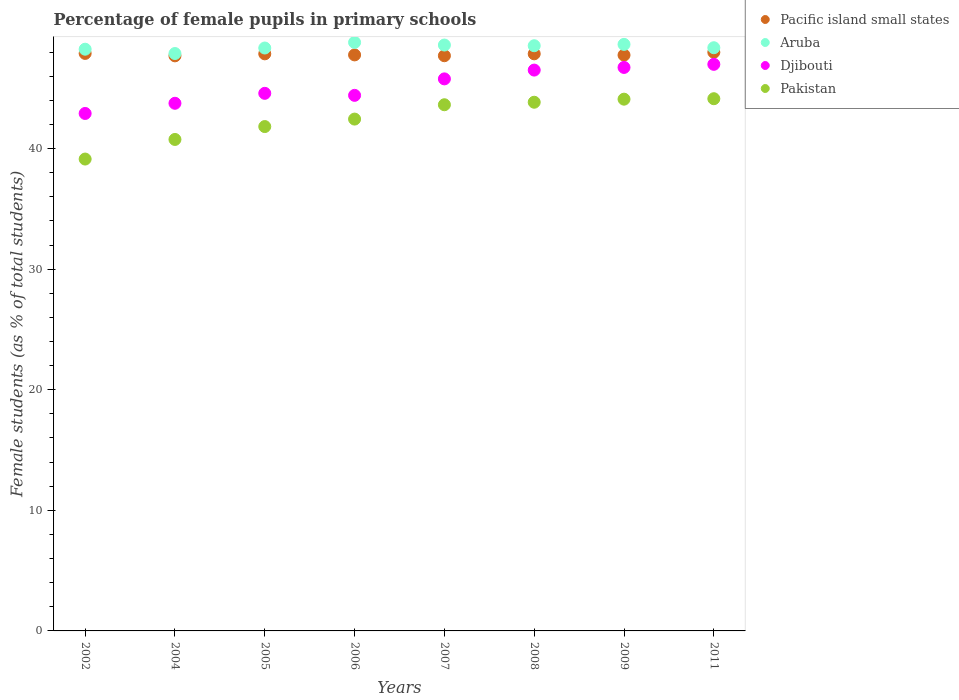What is the percentage of female pupils in primary schools in Pakistan in 2002?
Keep it short and to the point. 39.13. Across all years, what is the maximum percentage of female pupils in primary schools in Djibouti?
Offer a terse response. 46.99. Across all years, what is the minimum percentage of female pupils in primary schools in Pacific island small states?
Your response must be concise. 47.69. What is the total percentage of female pupils in primary schools in Pacific island small states in the graph?
Offer a very short reply. 382.52. What is the difference between the percentage of female pupils in primary schools in Djibouti in 2007 and that in 2011?
Your answer should be very brief. -1.21. What is the difference between the percentage of female pupils in primary schools in Djibouti in 2006 and the percentage of female pupils in primary schools in Pacific island small states in 2007?
Provide a short and direct response. -3.29. What is the average percentage of female pupils in primary schools in Djibouti per year?
Your answer should be very brief. 45.21. In the year 2008, what is the difference between the percentage of female pupils in primary schools in Pakistan and percentage of female pupils in primary schools in Djibouti?
Keep it short and to the point. -2.67. What is the ratio of the percentage of female pupils in primary schools in Pakistan in 2006 to that in 2007?
Keep it short and to the point. 0.97. Is the difference between the percentage of female pupils in primary schools in Pakistan in 2005 and 2007 greater than the difference between the percentage of female pupils in primary schools in Djibouti in 2005 and 2007?
Give a very brief answer. No. What is the difference between the highest and the second highest percentage of female pupils in primary schools in Pacific island small states?
Provide a short and direct response. 0.1. What is the difference between the highest and the lowest percentage of female pupils in primary schools in Aruba?
Offer a very short reply. 0.92. In how many years, is the percentage of female pupils in primary schools in Djibouti greater than the average percentage of female pupils in primary schools in Djibouti taken over all years?
Offer a terse response. 4. Is it the case that in every year, the sum of the percentage of female pupils in primary schools in Djibouti and percentage of female pupils in primary schools in Aruba  is greater than the sum of percentage of female pupils in primary schools in Pacific island small states and percentage of female pupils in primary schools in Pakistan?
Your answer should be compact. Yes. Is the percentage of female pupils in primary schools in Djibouti strictly less than the percentage of female pupils in primary schools in Pakistan over the years?
Your answer should be compact. No. How many dotlines are there?
Provide a succinct answer. 4. What is the difference between two consecutive major ticks on the Y-axis?
Make the answer very short. 10. Are the values on the major ticks of Y-axis written in scientific E-notation?
Your answer should be compact. No. Does the graph contain any zero values?
Provide a short and direct response. No. Where does the legend appear in the graph?
Offer a very short reply. Top right. How many legend labels are there?
Offer a very short reply. 4. How are the legend labels stacked?
Offer a very short reply. Vertical. What is the title of the graph?
Provide a short and direct response. Percentage of female pupils in primary schools. Does "Cameroon" appear as one of the legend labels in the graph?
Provide a short and direct response. No. What is the label or title of the X-axis?
Provide a short and direct response. Years. What is the label or title of the Y-axis?
Offer a terse response. Female students (as % of total students). What is the Female students (as % of total students) in Pacific island small states in 2002?
Provide a short and direct response. 47.89. What is the Female students (as % of total students) of Aruba in 2002?
Give a very brief answer. 48.24. What is the Female students (as % of total students) of Djibouti in 2002?
Ensure brevity in your answer.  42.91. What is the Female students (as % of total students) of Pakistan in 2002?
Offer a terse response. 39.13. What is the Female students (as % of total students) in Pacific island small states in 2004?
Make the answer very short. 47.69. What is the Female students (as % of total students) of Aruba in 2004?
Your answer should be very brief. 47.88. What is the Female students (as % of total students) in Djibouti in 2004?
Provide a short and direct response. 43.76. What is the Female students (as % of total students) in Pakistan in 2004?
Provide a short and direct response. 40.76. What is the Female students (as % of total students) of Pacific island small states in 2005?
Your answer should be compact. 47.86. What is the Female students (as % of total students) in Aruba in 2005?
Ensure brevity in your answer.  48.34. What is the Female students (as % of total students) of Djibouti in 2005?
Provide a short and direct response. 44.58. What is the Female students (as % of total students) in Pakistan in 2005?
Provide a succinct answer. 41.83. What is the Female students (as % of total students) in Pacific island small states in 2006?
Provide a short and direct response. 47.77. What is the Female students (as % of total students) of Aruba in 2006?
Provide a short and direct response. 48.81. What is the Female students (as % of total students) in Djibouti in 2006?
Give a very brief answer. 44.42. What is the Female students (as % of total students) in Pakistan in 2006?
Your answer should be compact. 42.45. What is the Female students (as % of total students) in Pacific island small states in 2007?
Provide a short and direct response. 47.7. What is the Female students (as % of total students) of Aruba in 2007?
Give a very brief answer. 48.59. What is the Female students (as % of total students) of Djibouti in 2007?
Your response must be concise. 45.78. What is the Female students (as % of total students) of Pakistan in 2007?
Keep it short and to the point. 43.64. What is the Female students (as % of total students) of Pacific island small states in 2008?
Offer a terse response. 47.86. What is the Female students (as % of total students) of Aruba in 2008?
Your answer should be very brief. 48.53. What is the Female students (as % of total students) in Djibouti in 2008?
Your response must be concise. 46.51. What is the Female students (as % of total students) of Pakistan in 2008?
Offer a very short reply. 43.84. What is the Female students (as % of total students) of Pacific island small states in 2009?
Give a very brief answer. 47.75. What is the Female students (as % of total students) in Aruba in 2009?
Provide a short and direct response. 48.64. What is the Female students (as % of total students) of Djibouti in 2009?
Keep it short and to the point. 46.73. What is the Female students (as % of total students) of Pakistan in 2009?
Give a very brief answer. 44.1. What is the Female students (as % of total students) in Pacific island small states in 2011?
Keep it short and to the point. 47.99. What is the Female students (as % of total students) of Aruba in 2011?
Your response must be concise. 48.36. What is the Female students (as % of total students) of Djibouti in 2011?
Offer a terse response. 46.99. What is the Female students (as % of total students) in Pakistan in 2011?
Give a very brief answer. 44.14. Across all years, what is the maximum Female students (as % of total students) of Pacific island small states?
Ensure brevity in your answer.  47.99. Across all years, what is the maximum Female students (as % of total students) in Aruba?
Provide a succinct answer. 48.81. Across all years, what is the maximum Female students (as % of total students) of Djibouti?
Ensure brevity in your answer.  46.99. Across all years, what is the maximum Female students (as % of total students) in Pakistan?
Offer a very short reply. 44.14. Across all years, what is the minimum Female students (as % of total students) of Pacific island small states?
Provide a succinct answer. 47.69. Across all years, what is the minimum Female students (as % of total students) of Aruba?
Your answer should be very brief. 47.88. Across all years, what is the minimum Female students (as % of total students) of Djibouti?
Keep it short and to the point. 42.91. Across all years, what is the minimum Female students (as % of total students) of Pakistan?
Your response must be concise. 39.13. What is the total Female students (as % of total students) in Pacific island small states in the graph?
Give a very brief answer. 382.52. What is the total Female students (as % of total students) in Aruba in the graph?
Make the answer very short. 387.4. What is the total Female students (as % of total students) in Djibouti in the graph?
Your response must be concise. 361.68. What is the total Female students (as % of total students) in Pakistan in the graph?
Your answer should be compact. 339.88. What is the difference between the Female students (as % of total students) of Pacific island small states in 2002 and that in 2004?
Your answer should be compact. 0.2. What is the difference between the Female students (as % of total students) of Aruba in 2002 and that in 2004?
Keep it short and to the point. 0.36. What is the difference between the Female students (as % of total students) of Djibouti in 2002 and that in 2004?
Make the answer very short. -0.84. What is the difference between the Female students (as % of total students) in Pakistan in 2002 and that in 2004?
Your answer should be very brief. -1.63. What is the difference between the Female students (as % of total students) in Pacific island small states in 2002 and that in 2005?
Your answer should be compact. 0.04. What is the difference between the Female students (as % of total students) of Aruba in 2002 and that in 2005?
Provide a short and direct response. -0.1. What is the difference between the Female students (as % of total students) in Djibouti in 2002 and that in 2005?
Your answer should be very brief. -1.67. What is the difference between the Female students (as % of total students) in Pakistan in 2002 and that in 2005?
Provide a succinct answer. -2.69. What is the difference between the Female students (as % of total students) in Pacific island small states in 2002 and that in 2006?
Offer a terse response. 0.12. What is the difference between the Female students (as % of total students) in Aruba in 2002 and that in 2006?
Make the answer very short. -0.56. What is the difference between the Female students (as % of total students) in Djibouti in 2002 and that in 2006?
Your answer should be compact. -1.5. What is the difference between the Female students (as % of total students) of Pakistan in 2002 and that in 2006?
Ensure brevity in your answer.  -3.31. What is the difference between the Female students (as % of total students) in Pacific island small states in 2002 and that in 2007?
Offer a very short reply. 0.19. What is the difference between the Female students (as % of total students) of Aruba in 2002 and that in 2007?
Give a very brief answer. -0.35. What is the difference between the Female students (as % of total students) in Djibouti in 2002 and that in 2007?
Ensure brevity in your answer.  -2.87. What is the difference between the Female students (as % of total students) in Pakistan in 2002 and that in 2007?
Ensure brevity in your answer.  -4.5. What is the difference between the Female students (as % of total students) of Pacific island small states in 2002 and that in 2008?
Your response must be concise. 0.03. What is the difference between the Female students (as % of total students) in Aruba in 2002 and that in 2008?
Offer a terse response. -0.29. What is the difference between the Female students (as % of total students) of Djibouti in 2002 and that in 2008?
Provide a succinct answer. -3.6. What is the difference between the Female students (as % of total students) of Pakistan in 2002 and that in 2008?
Make the answer very short. -4.71. What is the difference between the Female students (as % of total students) in Pacific island small states in 2002 and that in 2009?
Your answer should be compact. 0.14. What is the difference between the Female students (as % of total students) in Aruba in 2002 and that in 2009?
Your answer should be very brief. -0.4. What is the difference between the Female students (as % of total students) of Djibouti in 2002 and that in 2009?
Make the answer very short. -3.82. What is the difference between the Female students (as % of total students) of Pakistan in 2002 and that in 2009?
Your answer should be compact. -4.97. What is the difference between the Female students (as % of total students) in Pacific island small states in 2002 and that in 2011?
Your response must be concise. -0.1. What is the difference between the Female students (as % of total students) of Aruba in 2002 and that in 2011?
Provide a short and direct response. -0.12. What is the difference between the Female students (as % of total students) of Djibouti in 2002 and that in 2011?
Your response must be concise. -4.07. What is the difference between the Female students (as % of total students) of Pakistan in 2002 and that in 2011?
Your answer should be compact. -5. What is the difference between the Female students (as % of total students) of Pacific island small states in 2004 and that in 2005?
Ensure brevity in your answer.  -0.17. What is the difference between the Female students (as % of total students) of Aruba in 2004 and that in 2005?
Provide a succinct answer. -0.46. What is the difference between the Female students (as % of total students) in Djibouti in 2004 and that in 2005?
Make the answer very short. -0.83. What is the difference between the Female students (as % of total students) in Pakistan in 2004 and that in 2005?
Ensure brevity in your answer.  -1.07. What is the difference between the Female students (as % of total students) in Pacific island small states in 2004 and that in 2006?
Give a very brief answer. -0.08. What is the difference between the Female students (as % of total students) in Aruba in 2004 and that in 2006?
Your response must be concise. -0.92. What is the difference between the Female students (as % of total students) in Djibouti in 2004 and that in 2006?
Provide a short and direct response. -0.66. What is the difference between the Female students (as % of total students) in Pakistan in 2004 and that in 2006?
Provide a short and direct response. -1.69. What is the difference between the Female students (as % of total students) of Pacific island small states in 2004 and that in 2007?
Keep it short and to the point. -0.01. What is the difference between the Female students (as % of total students) of Aruba in 2004 and that in 2007?
Offer a terse response. -0.7. What is the difference between the Female students (as % of total students) in Djibouti in 2004 and that in 2007?
Offer a very short reply. -2.02. What is the difference between the Female students (as % of total students) in Pakistan in 2004 and that in 2007?
Keep it short and to the point. -2.88. What is the difference between the Female students (as % of total students) of Pacific island small states in 2004 and that in 2008?
Ensure brevity in your answer.  -0.17. What is the difference between the Female students (as % of total students) of Aruba in 2004 and that in 2008?
Offer a very short reply. -0.65. What is the difference between the Female students (as % of total students) of Djibouti in 2004 and that in 2008?
Give a very brief answer. -2.75. What is the difference between the Female students (as % of total students) of Pakistan in 2004 and that in 2008?
Keep it short and to the point. -3.09. What is the difference between the Female students (as % of total students) in Pacific island small states in 2004 and that in 2009?
Keep it short and to the point. -0.06. What is the difference between the Female students (as % of total students) of Aruba in 2004 and that in 2009?
Offer a terse response. -0.76. What is the difference between the Female students (as % of total students) of Djibouti in 2004 and that in 2009?
Your response must be concise. -2.97. What is the difference between the Female students (as % of total students) of Pakistan in 2004 and that in 2009?
Keep it short and to the point. -3.34. What is the difference between the Female students (as % of total students) of Pacific island small states in 2004 and that in 2011?
Ensure brevity in your answer.  -0.3. What is the difference between the Female students (as % of total students) of Aruba in 2004 and that in 2011?
Provide a short and direct response. -0.48. What is the difference between the Female students (as % of total students) in Djibouti in 2004 and that in 2011?
Keep it short and to the point. -3.23. What is the difference between the Female students (as % of total students) of Pakistan in 2004 and that in 2011?
Your answer should be very brief. -3.38. What is the difference between the Female students (as % of total students) of Pacific island small states in 2005 and that in 2006?
Your answer should be very brief. 0.09. What is the difference between the Female students (as % of total students) of Aruba in 2005 and that in 2006?
Provide a succinct answer. -0.47. What is the difference between the Female students (as % of total students) in Djibouti in 2005 and that in 2006?
Offer a very short reply. 0.17. What is the difference between the Female students (as % of total students) of Pakistan in 2005 and that in 2006?
Offer a terse response. -0.62. What is the difference between the Female students (as % of total students) of Pacific island small states in 2005 and that in 2007?
Your response must be concise. 0.16. What is the difference between the Female students (as % of total students) of Aruba in 2005 and that in 2007?
Keep it short and to the point. -0.25. What is the difference between the Female students (as % of total students) in Djibouti in 2005 and that in 2007?
Offer a terse response. -1.2. What is the difference between the Female students (as % of total students) of Pakistan in 2005 and that in 2007?
Ensure brevity in your answer.  -1.81. What is the difference between the Female students (as % of total students) of Pacific island small states in 2005 and that in 2008?
Offer a very short reply. -0. What is the difference between the Female students (as % of total students) of Aruba in 2005 and that in 2008?
Provide a short and direct response. -0.19. What is the difference between the Female students (as % of total students) in Djibouti in 2005 and that in 2008?
Ensure brevity in your answer.  -1.93. What is the difference between the Female students (as % of total students) of Pakistan in 2005 and that in 2008?
Your response must be concise. -2.02. What is the difference between the Female students (as % of total students) of Pacific island small states in 2005 and that in 2009?
Give a very brief answer. 0.1. What is the difference between the Female students (as % of total students) in Aruba in 2005 and that in 2009?
Offer a terse response. -0.3. What is the difference between the Female students (as % of total students) of Djibouti in 2005 and that in 2009?
Keep it short and to the point. -2.15. What is the difference between the Female students (as % of total students) in Pakistan in 2005 and that in 2009?
Provide a short and direct response. -2.27. What is the difference between the Female students (as % of total students) in Pacific island small states in 2005 and that in 2011?
Your answer should be compact. -0.13. What is the difference between the Female students (as % of total students) in Aruba in 2005 and that in 2011?
Your answer should be very brief. -0.02. What is the difference between the Female students (as % of total students) in Djibouti in 2005 and that in 2011?
Keep it short and to the point. -2.4. What is the difference between the Female students (as % of total students) in Pakistan in 2005 and that in 2011?
Your answer should be very brief. -2.31. What is the difference between the Female students (as % of total students) of Pacific island small states in 2006 and that in 2007?
Give a very brief answer. 0.07. What is the difference between the Female students (as % of total students) in Aruba in 2006 and that in 2007?
Keep it short and to the point. 0.22. What is the difference between the Female students (as % of total students) of Djibouti in 2006 and that in 2007?
Offer a very short reply. -1.37. What is the difference between the Female students (as % of total students) of Pakistan in 2006 and that in 2007?
Ensure brevity in your answer.  -1.19. What is the difference between the Female students (as % of total students) in Pacific island small states in 2006 and that in 2008?
Offer a very short reply. -0.09. What is the difference between the Female students (as % of total students) in Aruba in 2006 and that in 2008?
Offer a terse response. 0.27. What is the difference between the Female students (as % of total students) of Djibouti in 2006 and that in 2008?
Your answer should be very brief. -2.1. What is the difference between the Female students (as % of total students) in Pakistan in 2006 and that in 2008?
Your answer should be compact. -1.4. What is the difference between the Female students (as % of total students) of Pacific island small states in 2006 and that in 2009?
Your answer should be very brief. 0.02. What is the difference between the Female students (as % of total students) of Aruba in 2006 and that in 2009?
Give a very brief answer. 0.16. What is the difference between the Female students (as % of total students) in Djibouti in 2006 and that in 2009?
Offer a very short reply. -2.32. What is the difference between the Female students (as % of total students) in Pakistan in 2006 and that in 2009?
Keep it short and to the point. -1.65. What is the difference between the Female students (as % of total students) in Pacific island small states in 2006 and that in 2011?
Provide a succinct answer. -0.22. What is the difference between the Female students (as % of total students) in Aruba in 2006 and that in 2011?
Give a very brief answer. 0.44. What is the difference between the Female students (as % of total students) in Djibouti in 2006 and that in 2011?
Provide a succinct answer. -2.57. What is the difference between the Female students (as % of total students) in Pakistan in 2006 and that in 2011?
Offer a very short reply. -1.69. What is the difference between the Female students (as % of total students) in Pacific island small states in 2007 and that in 2008?
Offer a very short reply. -0.16. What is the difference between the Female students (as % of total students) in Aruba in 2007 and that in 2008?
Offer a terse response. 0.06. What is the difference between the Female students (as % of total students) in Djibouti in 2007 and that in 2008?
Keep it short and to the point. -0.73. What is the difference between the Female students (as % of total students) of Pakistan in 2007 and that in 2008?
Your answer should be very brief. -0.21. What is the difference between the Female students (as % of total students) in Pacific island small states in 2007 and that in 2009?
Make the answer very short. -0.05. What is the difference between the Female students (as % of total students) in Aruba in 2007 and that in 2009?
Provide a succinct answer. -0.05. What is the difference between the Female students (as % of total students) of Djibouti in 2007 and that in 2009?
Provide a succinct answer. -0.95. What is the difference between the Female students (as % of total students) of Pakistan in 2007 and that in 2009?
Provide a short and direct response. -0.46. What is the difference between the Female students (as % of total students) in Pacific island small states in 2007 and that in 2011?
Provide a succinct answer. -0.29. What is the difference between the Female students (as % of total students) of Aruba in 2007 and that in 2011?
Make the answer very short. 0.22. What is the difference between the Female students (as % of total students) in Djibouti in 2007 and that in 2011?
Your response must be concise. -1.21. What is the difference between the Female students (as % of total students) of Pakistan in 2007 and that in 2011?
Provide a short and direct response. -0.5. What is the difference between the Female students (as % of total students) in Pacific island small states in 2008 and that in 2009?
Your answer should be very brief. 0.11. What is the difference between the Female students (as % of total students) in Aruba in 2008 and that in 2009?
Provide a short and direct response. -0.11. What is the difference between the Female students (as % of total students) of Djibouti in 2008 and that in 2009?
Your answer should be compact. -0.22. What is the difference between the Female students (as % of total students) in Pakistan in 2008 and that in 2009?
Ensure brevity in your answer.  -0.25. What is the difference between the Female students (as % of total students) of Pacific island small states in 2008 and that in 2011?
Your response must be concise. -0.13. What is the difference between the Female students (as % of total students) in Aruba in 2008 and that in 2011?
Offer a very short reply. 0.17. What is the difference between the Female students (as % of total students) in Djibouti in 2008 and that in 2011?
Your answer should be compact. -0.48. What is the difference between the Female students (as % of total students) in Pakistan in 2008 and that in 2011?
Provide a short and direct response. -0.29. What is the difference between the Female students (as % of total students) in Pacific island small states in 2009 and that in 2011?
Offer a very short reply. -0.23. What is the difference between the Female students (as % of total students) of Aruba in 2009 and that in 2011?
Your response must be concise. 0.28. What is the difference between the Female students (as % of total students) of Djibouti in 2009 and that in 2011?
Keep it short and to the point. -0.26. What is the difference between the Female students (as % of total students) of Pakistan in 2009 and that in 2011?
Keep it short and to the point. -0.04. What is the difference between the Female students (as % of total students) in Pacific island small states in 2002 and the Female students (as % of total students) in Aruba in 2004?
Provide a short and direct response. 0.01. What is the difference between the Female students (as % of total students) of Pacific island small states in 2002 and the Female students (as % of total students) of Djibouti in 2004?
Provide a short and direct response. 4.14. What is the difference between the Female students (as % of total students) in Pacific island small states in 2002 and the Female students (as % of total students) in Pakistan in 2004?
Offer a terse response. 7.14. What is the difference between the Female students (as % of total students) of Aruba in 2002 and the Female students (as % of total students) of Djibouti in 2004?
Offer a very short reply. 4.48. What is the difference between the Female students (as % of total students) in Aruba in 2002 and the Female students (as % of total students) in Pakistan in 2004?
Your answer should be compact. 7.48. What is the difference between the Female students (as % of total students) of Djibouti in 2002 and the Female students (as % of total students) of Pakistan in 2004?
Provide a short and direct response. 2.16. What is the difference between the Female students (as % of total students) in Pacific island small states in 2002 and the Female students (as % of total students) in Aruba in 2005?
Ensure brevity in your answer.  -0.45. What is the difference between the Female students (as % of total students) in Pacific island small states in 2002 and the Female students (as % of total students) in Djibouti in 2005?
Provide a succinct answer. 3.31. What is the difference between the Female students (as % of total students) of Pacific island small states in 2002 and the Female students (as % of total students) of Pakistan in 2005?
Make the answer very short. 6.07. What is the difference between the Female students (as % of total students) of Aruba in 2002 and the Female students (as % of total students) of Djibouti in 2005?
Offer a terse response. 3.66. What is the difference between the Female students (as % of total students) of Aruba in 2002 and the Female students (as % of total students) of Pakistan in 2005?
Provide a succinct answer. 6.41. What is the difference between the Female students (as % of total students) in Djibouti in 2002 and the Female students (as % of total students) in Pakistan in 2005?
Your answer should be very brief. 1.09. What is the difference between the Female students (as % of total students) of Pacific island small states in 2002 and the Female students (as % of total students) of Aruba in 2006?
Offer a terse response. -0.91. What is the difference between the Female students (as % of total students) of Pacific island small states in 2002 and the Female students (as % of total students) of Djibouti in 2006?
Provide a short and direct response. 3.48. What is the difference between the Female students (as % of total students) of Pacific island small states in 2002 and the Female students (as % of total students) of Pakistan in 2006?
Ensure brevity in your answer.  5.45. What is the difference between the Female students (as % of total students) in Aruba in 2002 and the Female students (as % of total students) in Djibouti in 2006?
Your answer should be compact. 3.83. What is the difference between the Female students (as % of total students) of Aruba in 2002 and the Female students (as % of total students) of Pakistan in 2006?
Keep it short and to the point. 5.79. What is the difference between the Female students (as % of total students) of Djibouti in 2002 and the Female students (as % of total students) of Pakistan in 2006?
Your answer should be very brief. 0.47. What is the difference between the Female students (as % of total students) of Pacific island small states in 2002 and the Female students (as % of total students) of Aruba in 2007?
Your answer should be very brief. -0.7. What is the difference between the Female students (as % of total students) of Pacific island small states in 2002 and the Female students (as % of total students) of Djibouti in 2007?
Ensure brevity in your answer.  2.11. What is the difference between the Female students (as % of total students) of Pacific island small states in 2002 and the Female students (as % of total students) of Pakistan in 2007?
Make the answer very short. 4.26. What is the difference between the Female students (as % of total students) of Aruba in 2002 and the Female students (as % of total students) of Djibouti in 2007?
Offer a very short reply. 2.46. What is the difference between the Female students (as % of total students) in Aruba in 2002 and the Female students (as % of total students) in Pakistan in 2007?
Offer a very short reply. 4.61. What is the difference between the Female students (as % of total students) of Djibouti in 2002 and the Female students (as % of total students) of Pakistan in 2007?
Offer a terse response. -0.72. What is the difference between the Female students (as % of total students) of Pacific island small states in 2002 and the Female students (as % of total students) of Aruba in 2008?
Your answer should be very brief. -0.64. What is the difference between the Female students (as % of total students) of Pacific island small states in 2002 and the Female students (as % of total students) of Djibouti in 2008?
Provide a short and direct response. 1.38. What is the difference between the Female students (as % of total students) in Pacific island small states in 2002 and the Female students (as % of total students) in Pakistan in 2008?
Your answer should be compact. 4.05. What is the difference between the Female students (as % of total students) in Aruba in 2002 and the Female students (as % of total students) in Djibouti in 2008?
Offer a terse response. 1.73. What is the difference between the Female students (as % of total students) of Aruba in 2002 and the Female students (as % of total students) of Pakistan in 2008?
Provide a short and direct response. 4.4. What is the difference between the Female students (as % of total students) in Djibouti in 2002 and the Female students (as % of total students) in Pakistan in 2008?
Your answer should be compact. -0.93. What is the difference between the Female students (as % of total students) in Pacific island small states in 2002 and the Female students (as % of total students) in Aruba in 2009?
Keep it short and to the point. -0.75. What is the difference between the Female students (as % of total students) of Pacific island small states in 2002 and the Female students (as % of total students) of Djibouti in 2009?
Offer a very short reply. 1.16. What is the difference between the Female students (as % of total students) of Pacific island small states in 2002 and the Female students (as % of total students) of Pakistan in 2009?
Keep it short and to the point. 3.79. What is the difference between the Female students (as % of total students) in Aruba in 2002 and the Female students (as % of total students) in Djibouti in 2009?
Give a very brief answer. 1.51. What is the difference between the Female students (as % of total students) in Aruba in 2002 and the Female students (as % of total students) in Pakistan in 2009?
Ensure brevity in your answer.  4.14. What is the difference between the Female students (as % of total students) of Djibouti in 2002 and the Female students (as % of total students) of Pakistan in 2009?
Offer a very short reply. -1.18. What is the difference between the Female students (as % of total students) of Pacific island small states in 2002 and the Female students (as % of total students) of Aruba in 2011?
Your answer should be very brief. -0.47. What is the difference between the Female students (as % of total students) of Pacific island small states in 2002 and the Female students (as % of total students) of Djibouti in 2011?
Your answer should be very brief. 0.91. What is the difference between the Female students (as % of total students) of Pacific island small states in 2002 and the Female students (as % of total students) of Pakistan in 2011?
Provide a succinct answer. 3.76. What is the difference between the Female students (as % of total students) in Aruba in 2002 and the Female students (as % of total students) in Djibouti in 2011?
Provide a succinct answer. 1.25. What is the difference between the Female students (as % of total students) in Aruba in 2002 and the Female students (as % of total students) in Pakistan in 2011?
Provide a succinct answer. 4.11. What is the difference between the Female students (as % of total students) of Djibouti in 2002 and the Female students (as % of total students) of Pakistan in 2011?
Provide a succinct answer. -1.22. What is the difference between the Female students (as % of total students) of Pacific island small states in 2004 and the Female students (as % of total students) of Aruba in 2005?
Give a very brief answer. -0.65. What is the difference between the Female students (as % of total students) in Pacific island small states in 2004 and the Female students (as % of total students) in Djibouti in 2005?
Keep it short and to the point. 3.11. What is the difference between the Female students (as % of total students) in Pacific island small states in 2004 and the Female students (as % of total students) in Pakistan in 2005?
Offer a very short reply. 5.86. What is the difference between the Female students (as % of total students) of Aruba in 2004 and the Female students (as % of total students) of Djibouti in 2005?
Offer a terse response. 3.3. What is the difference between the Female students (as % of total students) of Aruba in 2004 and the Female students (as % of total students) of Pakistan in 2005?
Your answer should be compact. 6.06. What is the difference between the Female students (as % of total students) in Djibouti in 2004 and the Female students (as % of total students) in Pakistan in 2005?
Ensure brevity in your answer.  1.93. What is the difference between the Female students (as % of total students) in Pacific island small states in 2004 and the Female students (as % of total students) in Aruba in 2006?
Provide a succinct answer. -1.11. What is the difference between the Female students (as % of total students) of Pacific island small states in 2004 and the Female students (as % of total students) of Djibouti in 2006?
Provide a succinct answer. 3.28. What is the difference between the Female students (as % of total students) of Pacific island small states in 2004 and the Female students (as % of total students) of Pakistan in 2006?
Your response must be concise. 5.24. What is the difference between the Female students (as % of total students) of Aruba in 2004 and the Female students (as % of total students) of Djibouti in 2006?
Provide a succinct answer. 3.47. What is the difference between the Female students (as % of total students) of Aruba in 2004 and the Female students (as % of total students) of Pakistan in 2006?
Provide a short and direct response. 5.44. What is the difference between the Female students (as % of total students) of Djibouti in 2004 and the Female students (as % of total students) of Pakistan in 2006?
Ensure brevity in your answer.  1.31. What is the difference between the Female students (as % of total students) of Pacific island small states in 2004 and the Female students (as % of total students) of Aruba in 2007?
Your response must be concise. -0.9. What is the difference between the Female students (as % of total students) in Pacific island small states in 2004 and the Female students (as % of total students) in Djibouti in 2007?
Your answer should be very brief. 1.91. What is the difference between the Female students (as % of total students) of Pacific island small states in 2004 and the Female students (as % of total students) of Pakistan in 2007?
Your answer should be very brief. 4.06. What is the difference between the Female students (as % of total students) in Aruba in 2004 and the Female students (as % of total students) in Djibouti in 2007?
Provide a succinct answer. 2.1. What is the difference between the Female students (as % of total students) of Aruba in 2004 and the Female students (as % of total students) of Pakistan in 2007?
Make the answer very short. 4.25. What is the difference between the Female students (as % of total students) in Djibouti in 2004 and the Female students (as % of total students) in Pakistan in 2007?
Ensure brevity in your answer.  0.12. What is the difference between the Female students (as % of total students) in Pacific island small states in 2004 and the Female students (as % of total students) in Aruba in 2008?
Make the answer very short. -0.84. What is the difference between the Female students (as % of total students) of Pacific island small states in 2004 and the Female students (as % of total students) of Djibouti in 2008?
Give a very brief answer. 1.18. What is the difference between the Female students (as % of total students) of Pacific island small states in 2004 and the Female students (as % of total students) of Pakistan in 2008?
Your response must be concise. 3.85. What is the difference between the Female students (as % of total students) of Aruba in 2004 and the Female students (as % of total students) of Djibouti in 2008?
Provide a succinct answer. 1.37. What is the difference between the Female students (as % of total students) in Aruba in 2004 and the Female students (as % of total students) in Pakistan in 2008?
Your response must be concise. 4.04. What is the difference between the Female students (as % of total students) in Djibouti in 2004 and the Female students (as % of total students) in Pakistan in 2008?
Your answer should be compact. -0.09. What is the difference between the Female students (as % of total students) in Pacific island small states in 2004 and the Female students (as % of total students) in Aruba in 2009?
Make the answer very short. -0.95. What is the difference between the Female students (as % of total students) in Pacific island small states in 2004 and the Female students (as % of total students) in Djibouti in 2009?
Your answer should be very brief. 0.96. What is the difference between the Female students (as % of total students) of Pacific island small states in 2004 and the Female students (as % of total students) of Pakistan in 2009?
Provide a short and direct response. 3.59. What is the difference between the Female students (as % of total students) in Aruba in 2004 and the Female students (as % of total students) in Djibouti in 2009?
Provide a short and direct response. 1.15. What is the difference between the Female students (as % of total students) in Aruba in 2004 and the Female students (as % of total students) in Pakistan in 2009?
Your answer should be very brief. 3.79. What is the difference between the Female students (as % of total students) in Djibouti in 2004 and the Female students (as % of total students) in Pakistan in 2009?
Give a very brief answer. -0.34. What is the difference between the Female students (as % of total students) of Pacific island small states in 2004 and the Female students (as % of total students) of Aruba in 2011?
Offer a terse response. -0.67. What is the difference between the Female students (as % of total students) of Pacific island small states in 2004 and the Female students (as % of total students) of Djibouti in 2011?
Your answer should be compact. 0.7. What is the difference between the Female students (as % of total students) of Pacific island small states in 2004 and the Female students (as % of total students) of Pakistan in 2011?
Your answer should be compact. 3.56. What is the difference between the Female students (as % of total students) of Aruba in 2004 and the Female students (as % of total students) of Djibouti in 2011?
Your response must be concise. 0.9. What is the difference between the Female students (as % of total students) in Aruba in 2004 and the Female students (as % of total students) in Pakistan in 2011?
Your answer should be compact. 3.75. What is the difference between the Female students (as % of total students) of Djibouti in 2004 and the Female students (as % of total students) of Pakistan in 2011?
Your answer should be very brief. -0.38. What is the difference between the Female students (as % of total students) of Pacific island small states in 2005 and the Female students (as % of total students) of Aruba in 2006?
Your answer should be compact. -0.95. What is the difference between the Female students (as % of total students) of Pacific island small states in 2005 and the Female students (as % of total students) of Djibouti in 2006?
Offer a very short reply. 3.44. What is the difference between the Female students (as % of total students) of Pacific island small states in 2005 and the Female students (as % of total students) of Pakistan in 2006?
Make the answer very short. 5.41. What is the difference between the Female students (as % of total students) of Aruba in 2005 and the Female students (as % of total students) of Djibouti in 2006?
Offer a terse response. 3.93. What is the difference between the Female students (as % of total students) in Aruba in 2005 and the Female students (as % of total students) in Pakistan in 2006?
Offer a terse response. 5.89. What is the difference between the Female students (as % of total students) of Djibouti in 2005 and the Female students (as % of total students) of Pakistan in 2006?
Offer a very short reply. 2.14. What is the difference between the Female students (as % of total students) in Pacific island small states in 2005 and the Female students (as % of total students) in Aruba in 2007?
Offer a very short reply. -0.73. What is the difference between the Female students (as % of total students) in Pacific island small states in 2005 and the Female students (as % of total students) in Djibouti in 2007?
Your answer should be very brief. 2.08. What is the difference between the Female students (as % of total students) of Pacific island small states in 2005 and the Female students (as % of total students) of Pakistan in 2007?
Provide a short and direct response. 4.22. What is the difference between the Female students (as % of total students) in Aruba in 2005 and the Female students (as % of total students) in Djibouti in 2007?
Your answer should be very brief. 2.56. What is the difference between the Female students (as % of total students) of Aruba in 2005 and the Female students (as % of total students) of Pakistan in 2007?
Give a very brief answer. 4.71. What is the difference between the Female students (as % of total students) in Djibouti in 2005 and the Female students (as % of total students) in Pakistan in 2007?
Your answer should be compact. 0.95. What is the difference between the Female students (as % of total students) in Pacific island small states in 2005 and the Female students (as % of total students) in Aruba in 2008?
Give a very brief answer. -0.67. What is the difference between the Female students (as % of total students) in Pacific island small states in 2005 and the Female students (as % of total students) in Djibouti in 2008?
Offer a very short reply. 1.35. What is the difference between the Female students (as % of total students) of Pacific island small states in 2005 and the Female students (as % of total students) of Pakistan in 2008?
Offer a terse response. 4.01. What is the difference between the Female students (as % of total students) in Aruba in 2005 and the Female students (as % of total students) in Djibouti in 2008?
Provide a short and direct response. 1.83. What is the difference between the Female students (as % of total students) in Aruba in 2005 and the Female students (as % of total students) in Pakistan in 2008?
Ensure brevity in your answer.  4.5. What is the difference between the Female students (as % of total students) of Djibouti in 2005 and the Female students (as % of total students) of Pakistan in 2008?
Provide a short and direct response. 0.74. What is the difference between the Female students (as % of total students) of Pacific island small states in 2005 and the Female students (as % of total students) of Aruba in 2009?
Ensure brevity in your answer.  -0.78. What is the difference between the Female students (as % of total students) of Pacific island small states in 2005 and the Female students (as % of total students) of Djibouti in 2009?
Give a very brief answer. 1.13. What is the difference between the Female students (as % of total students) in Pacific island small states in 2005 and the Female students (as % of total students) in Pakistan in 2009?
Your answer should be compact. 3.76. What is the difference between the Female students (as % of total students) in Aruba in 2005 and the Female students (as % of total students) in Djibouti in 2009?
Offer a terse response. 1.61. What is the difference between the Female students (as % of total students) of Aruba in 2005 and the Female students (as % of total students) of Pakistan in 2009?
Provide a succinct answer. 4.24. What is the difference between the Female students (as % of total students) in Djibouti in 2005 and the Female students (as % of total students) in Pakistan in 2009?
Provide a succinct answer. 0.48. What is the difference between the Female students (as % of total students) in Pacific island small states in 2005 and the Female students (as % of total students) in Aruba in 2011?
Offer a terse response. -0.51. What is the difference between the Female students (as % of total students) of Pacific island small states in 2005 and the Female students (as % of total students) of Djibouti in 2011?
Provide a succinct answer. 0.87. What is the difference between the Female students (as % of total students) of Pacific island small states in 2005 and the Female students (as % of total students) of Pakistan in 2011?
Provide a succinct answer. 3.72. What is the difference between the Female students (as % of total students) in Aruba in 2005 and the Female students (as % of total students) in Djibouti in 2011?
Keep it short and to the point. 1.35. What is the difference between the Female students (as % of total students) of Aruba in 2005 and the Female students (as % of total students) of Pakistan in 2011?
Your response must be concise. 4.2. What is the difference between the Female students (as % of total students) of Djibouti in 2005 and the Female students (as % of total students) of Pakistan in 2011?
Offer a very short reply. 0.45. What is the difference between the Female students (as % of total students) of Pacific island small states in 2006 and the Female students (as % of total students) of Aruba in 2007?
Your response must be concise. -0.82. What is the difference between the Female students (as % of total students) of Pacific island small states in 2006 and the Female students (as % of total students) of Djibouti in 2007?
Your answer should be very brief. 1.99. What is the difference between the Female students (as % of total students) in Pacific island small states in 2006 and the Female students (as % of total students) in Pakistan in 2007?
Offer a terse response. 4.13. What is the difference between the Female students (as % of total students) of Aruba in 2006 and the Female students (as % of total students) of Djibouti in 2007?
Your response must be concise. 3.02. What is the difference between the Female students (as % of total students) of Aruba in 2006 and the Female students (as % of total students) of Pakistan in 2007?
Make the answer very short. 5.17. What is the difference between the Female students (as % of total students) in Djibouti in 2006 and the Female students (as % of total students) in Pakistan in 2007?
Provide a succinct answer. 0.78. What is the difference between the Female students (as % of total students) in Pacific island small states in 2006 and the Female students (as % of total students) in Aruba in 2008?
Your response must be concise. -0.76. What is the difference between the Female students (as % of total students) of Pacific island small states in 2006 and the Female students (as % of total students) of Djibouti in 2008?
Keep it short and to the point. 1.26. What is the difference between the Female students (as % of total students) in Pacific island small states in 2006 and the Female students (as % of total students) in Pakistan in 2008?
Offer a very short reply. 3.93. What is the difference between the Female students (as % of total students) in Aruba in 2006 and the Female students (as % of total students) in Djibouti in 2008?
Give a very brief answer. 2.3. What is the difference between the Female students (as % of total students) in Aruba in 2006 and the Female students (as % of total students) in Pakistan in 2008?
Ensure brevity in your answer.  4.96. What is the difference between the Female students (as % of total students) in Djibouti in 2006 and the Female students (as % of total students) in Pakistan in 2008?
Offer a terse response. 0.57. What is the difference between the Female students (as % of total students) in Pacific island small states in 2006 and the Female students (as % of total students) in Aruba in 2009?
Provide a succinct answer. -0.87. What is the difference between the Female students (as % of total students) in Pacific island small states in 2006 and the Female students (as % of total students) in Djibouti in 2009?
Provide a succinct answer. 1.04. What is the difference between the Female students (as % of total students) of Pacific island small states in 2006 and the Female students (as % of total students) of Pakistan in 2009?
Provide a short and direct response. 3.67. What is the difference between the Female students (as % of total students) of Aruba in 2006 and the Female students (as % of total students) of Djibouti in 2009?
Ensure brevity in your answer.  2.08. What is the difference between the Female students (as % of total students) of Aruba in 2006 and the Female students (as % of total students) of Pakistan in 2009?
Give a very brief answer. 4.71. What is the difference between the Female students (as % of total students) of Djibouti in 2006 and the Female students (as % of total students) of Pakistan in 2009?
Provide a short and direct response. 0.32. What is the difference between the Female students (as % of total students) in Pacific island small states in 2006 and the Female students (as % of total students) in Aruba in 2011?
Your answer should be very brief. -0.59. What is the difference between the Female students (as % of total students) in Pacific island small states in 2006 and the Female students (as % of total students) in Djibouti in 2011?
Keep it short and to the point. 0.78. What is the difference between the Female students (as % of total students) in Pacific island small states in 2006 and the Female students (as % of total students) in Pakistan in 2011?
Provide a short and direct response. 3.63. What is the difference between the Female students (as % of total students) in Aruba in 2006 and the Female students (as % of total students) in Djibouti in 2011?
Offer a terse response. 1.82. What is the difference between the Female students (as % of total students) in Aruba in 2006 and the Female students (as % of total students) in Pakistan in 2011?
Your answer should be compact. 4.67. What is the difference between the Female students (as % of total students) of Djibouti in 2006 and the Female students (as % of total students) of Pakistan in 2011?
Provide a succinct answer. 0.28. What is the difference between the Female students (as % of total students) of Pacific island small states in 2007 and the Female students (as % of total students) of Aruba in 2008?
Keep it short and to the point. -0.83. What is the difference between the Female students (as % of total students) in Pacific island small states in 2007 and the Female students (as % of total students) in Djibouti in 2008?
Give a very brief answer. 1.19. What is the difference between the Female students (as % of total students) of Pacific island small states in 2007 and the Female students (as % of total students) of Pakistan in 2008?
Give a very brief answer. 3.86. What is the difference between the Female students (as % of total students) in Aruba in 2007 and the Female students (as % of total students) in Djibouti in 2008?
Keep it short and to the point. 2.08. What is the difference between the Female students (as % of total students) in Aruba in 2007 and the Female students (as % of total students) in Pakistan in 2008?
Your answer should be very brief. 4.74. What is the difference between the Female students (as % of total students) in Djibouti in 2007 and the Female students (as % of total students) in Pakistan in 2008?
Your response must be concise. 1.94. What is the difference between the Female students (as % of total students) in Pacific island small states in 2007 and the Female students (as % of total students) in Aruba in 2009?
Keep it short and to the point. -0.94. What is the difference between the Female students (as % of total students) of Pacific island small states in 2007 and the Female students (as % of total students) of Djibouti in 2009?
Your answer should be compact. 0.97. What is the difference between the Female students (as % of total students) of Pacific island small states in 2007 and the Female students (as % of total students) of Pakistan in 2009?
Your answer should be very brief. 3.6. What is the difference between the Female students (as % of total students) in Aruba in 2007 and the Female students (as % of total students) in Djibouti in 2009?
Offer a terse response. 1.86. What is the difference between the Female students (as % of total students) of Aruba in 2007 and the Female students (as % of total students) of Pakistan in 2009?
Your answer should be very brief. 4.49. What is the difference between the Female students (as % of total students) in Djibouti in 2007 and the Female students (as % of total students) in Pakistan in 2009?
Offer a terse response. 1.68. What is the difference between the Female students (as % of total students) of Pacific island small states in 2007 and the Female students (as % of total students) of Aruba in 2011?
Your response must be concise. -0.66. What is the difference between the Female students (as % of total students) of Pacific island small states in 2007 and the Female students (as % of total students) of Djibouti in 2011?
Offer a very short reply. 0.71. What is the difference between the Female students (as % of total students) of Pacific island small states in 2007 and the Female students (as % of total students) of Pakistan in 2011?
Provide a succinct answer. 3.56. What is the difference between the Female students (as % of total students) of Aruba in 2007 and the Female students (as % of total students) of Djibouti in 2011?
Make the answer very short. 1.6. What is the difference between the Female students (as % of total students) in Aruba in 2007 and the Female students (as % of total students) in Pakistan in 2011?
Provide a succinct answer. 4.45. What is the difference between the Female students (as % of total students) in Djibouti in 2007 and the Female students (as % of total students) in Pakistan in 2011?
Your answer should be very brief. 1.64. What is the difference between the Female students (as % of total students) in Pacific island small states in 2008 and the Female students (as % of total students) in Aruba in 2009?
Provide a succinct answer. -0.78. What is the difference between the Female students (as % of total students) of Pacific island small states in 2008 and the Female students (as % of total students) of Djibouti in 2009?
Your response must be concise. 1.13. What is the difference between the Female students (as % of total students) in Pacific island small states in 2008 and the Female students (as % of total students) in Pakistan in 2009?
Give a very brief answer. 3.76. What is the difference between the Female students (as % of total students) of Aruba in 2008 and the Female students (as % of total students) of Djibouti in 2009?
Make the answer very short. 1.8. What is the difference between the Female students (as % of total students) of Aruba in 2008 and the Female students (as % of total students) of Pakistan in 2009?
Make the answer very short. 4.43. What is the difference between the Female students (as % of total students) of Djibouti in 2008 and the Female students (as % of total students) of Pakistan in 2009?
Make the answer very short. 2.41. What is the difference between the Female students (as % of total students) of Pacific island small states in 2008 and the Female students (as % of total students) of Aruba in 2011?
Make the answer very short. -0.5. What is the difference between the Female students (as % of total students) in Pacific island small states in 2008 and the Female students (as % of total students) in Djibouti in 2011?
Provide a short and direct response. 0.87. What is the difference between the Female students (as % of total students) in Pacific island small states in 2008 and the Female students (as % of total students) in Pakistan in 2011?
Provide a short and direct response. 3.72. What is the difference between the Female students (as % of total students) in Aruba in 2008 and the Female students (as % of total students) in Djibouti in 2011?
Make the answer very short. 1.54. What is the difference between the Female students (as % of total students) in Aruba in 2008 and the Female students (as % of total students) in Pakistan in 2011?
Your answer should be very brief. 4.39. What is the difference between the Female students (as % of total students) of Djibouti in 2008 and the Female students (as % of total students) of Pakistan in 2011?
Your answer should be compact. 2.37. What is the difference between the Female students (as % of total students) of Pacific island small states in 2009 and the Female students (as % of total students) of Aruba in 2011?
Your answer should be compact. -0.61. What is the difference between the Female students (as % of total students) of Pacific island small states in 2009 and the Female students (as % of total students) of Djibouti in 2011?
Your response must be concise. 0.77. What is the difference between the Female students (as % of total students) in Pacific island small states in 2009 and the Female students (as % of total students) in Pakistan in 2011?
Ensure brevity in your answer.  3.62. What is the difference between the Female students (as % of total students) of Aruba in 2009 and the Female students (as % of total students) of Djibouti in 2011?
Your response must be concise. 1.65. What is the difference between the Female students (as % of total students) in Aruba in 2009 and the Female students (as % of total students) in Pakistan in 2011?
Offer a very short reply. 4.51. What is the difference between the Female students (as % of total students) in Djibouti in 2009 and the Female students (as % of total students) in Pakistan in 2011?
Keep it short and to the point. 2.59. What is the average Female students (as % of total students) in Pacific island small states per year?
Provide a short and direct response. 47.81. What is the average Female students (as % of total students) in Aruba per year?
Keep it short and to the point. 48.43. What is the average Female students (as % of total students) in Djibouti per year?
Your response must be concise. 45.21. What is the average Female students (as % of total students) of Pakistan per year?
Make the answer very short. 42.49. In the year 2002, what is the difference between the Female students (as % of total students) in Pacific island small states and Female students (as % of total students) in Aruba?
Offer a terse response. -0.35. In the year 2002, what is the difference between the Female students (as % of total students) in Pacific island small states and Female students (as % of total students) in Djibouti?
Keep it short and to the point. 4.98. In the year 2002, what is the difference between the Female students (as % of total students) in Pacific island small states and Female students (as % of total students) in Pakistan?
Your answer should be compact. 8.76. In the year 2002, what is the difference between the Female students (as % of total students) of Aruba and Female students (as % of total students) of Djibouti?
Give a very brief answer. 5.33. In the year 2002, what is the difference between the Female students (as % of total students) of Aruba and Female students (as % of total students) of Pakistan?
Offer a very short reply. 9.11. In the year 2002, what is the difference between the Female students (as % of total students) in Djibouti and Female students (as % of total students) in Pakistan?
Make the answer very short. 3.78. In the year 2004, what is the difference between the Female students (as % of total students) of Pacific island small states and Female students (as % of total students) of Aruba?
Offer a terse response. -0.19. In the year 2004, what is the difference between the Female students (as % of total students) of Pacific island small states and Female students (as % of total students) of Djibouti?
Your answer should be compact. 3.93. In the year 2004, what is the difference between the Female students (as % of total students) of Pacific island small states and Female students (as % of total students) of Pakistan?
Your response must be concise. 6.93. In the year 2004, what is the difference between the Female students (as % of total students) of Aruba and Female students (as % of total students) of Djibouti?
Your answer should be compact. 4.13. In the year 2004, what is the difference between the Female students (as % of total students) of Aruba and Female students (as % of total students) of Pakistan?
Your answer should be very brief. 7.13. In the year 2005, what is the difference between the Female students (as % of total students) in Pacific island small states and Female students (as % of total students) in Aruba?
Your response must be concise. -0.48. In the year 2005, what is the difference between the Female students (as % of total students) in Pacific island small states and Female students (as % of total students) in Djibouti?
Your answer should be compact. 3.27. In the year 2005, what is the difference between the Female students (as % of total students) in Pacific island small states and Female students (as % of total students) in Pakistan?
Your answer should be very brief. 6.03. In the year 2005, what is the difference between the Female students (as % of total students) of Aruba and Female students (as % of total students) of Djibouti?
Your answer should be very brief. 3.76. In the year 2005, what is the difference between the Female students (as % of total students) of Aruba and Female students (as % of total students) of Pakistan?
Give a very brief answer. 6.51. In the year 2005, what is the difference between the Female students (as % of total students) in Djibouti and Female students (as % of total students) in Pakistan?
Provide a succinct answer. 2.76. In the year 2006, what is the difference between the Female students (as % of total students) in Pacific island small states and Female students (as % of total students) in Aruba?
Provide a succinct answer. -1.04. In the year 2006, what is the difference between the Female students (as % of total students) of Pacific island small states and Female students (as % of total students) of Djibouti?
Your answer should be compact. 3.35. In the year 2006, what is the difference between the Female students (as % of total students) of Pacific island small states and Female students (as % of total students) of Pakistan?
Make the answer very short. 5.32. In the year 2006, what is the difference between the Female students (as % of total students) in Aruba and Female students (as % of total students) in Djibouti?
Offer a terse response. 4.39. In the year 2006, what is the difference between the Female students (as % of total students) in Aruba and Female students (as % of total students) in Pakistan?
Offer a very short reply. 6.36. In the year 2006, what is the difference between the Female students (as % of total students) in Djibouti and Female students (as % of total students) in Pakistan?
Provide a short and direct response. 1.97. In the year 2007, what is the difference between the Female students (as % of total students) in Pacific island small states and Female students (as % of total students) in Aruba?
Make the answer very short. -0.89. In the year 2007, what is the difference between the Female students (as % of total students) in Pacific island small states and Female students (as % of total students) in Djibouti?
Provide a succinct answer. 1.92. In the year 2007, what is the difference between the Female students (as % of total students) in Pacific island small states and Female students (as % of total students) in Pakistan?
Keep it short and to the point. 4.07. In the year 2007, what is the difference between the Female students (as % of total students) of Aruba and Female students (as % of total students) of Djibouti?
Provide a succinct answer. 2.81. In the year 2007, what is the difference between the Female students (as % of total students) of Aruba and Female students (as % of total students) of Pakistan?
Your answer should be compact. 4.95. In the year 2007, what is the difference between the Female students (as % of total students) of Djibouti and Female students (as % of total students) of Pakistan?
Keep it short and to the point. 2.15. In the year 2008, what is the difference between the Female students (as % of total students) of Pacific island small states and Female students (as % of total students) of Aruba?
Make the answer very short. -0.67. In the year 2008, what is the difference between the Female students (as % of total students) in Pacific island small states and Female students (as % of total students) in Djibouti?
Provide a succinct answer. 1.35. In the year 2008, what is the difference between the Female students (as % of total students) in Pacific island small states and Female students (as % of total students) in Pakistan?
Your response must be concise. 4.02. In the year 2008, what is the difference between the Female students (as % of total students) of Aruba and Female students (as % of total students) of Djibouti?
Offer a very short reply. 2.02. In the year 2008, what is the difference between the Female students (as % of total students) in Aruba and Female students (as % of total students) in Pakistan?
Offer a terse response. 4.69. In the year 2008, what is the difference between the Female students (as % of total students) in Djibouti and Female students (as % of total students) in Pakistan?
Keep it short and to the point. 2.67. In the year 2009, what is the difference between the Female students (as % of total students) of Pacific island small states and Female students (as % of total students) of Aruba?
Keep it short and to the point. -0.89. In the year 2009, what is the difference between the Female students (as % of total students) in Pacific island small states and Female students (as % of total students) in Djibouti?
Make the answer very short. 1.02. In the year 2009, what is the difference between the Female students (as % of total students) of Pacific island small states and Female students (as % of total students) of Pakistan?
Your answer should be compact. 3.66. In the year 2009, what is the difference between the Female students (as % of total students) in Aruba and Female students (as % of total students) in Djibouti?
Your response must be concise. 1.91. In the year 2009, what is the difference between the Female students (as % of total students) of Aruba and Female students (as % of total students) of Pakistan?
Give a very brief answer. 4.54. In the year 2009, what is the difference between the Female students (as % of total students) of Djibouti and Female students (as % of total students) of Pakistan?
Provide a succinct answer. 2.63. In the year 2011, what is the difference between the Female students (as % of total students) of Pacific island small states and Female students (as % of total students) of Aruba?
Offer a terse response. -0.38. In the year 2011, what is the difference between the Female students (as % of total students) in Pacific island small states and Female students (as % of total students) in Djibouti?
Keep it short and to the point. 1. In the year 2011, what is the difference between the Female students (as % of total students) in Pacific island small states and Female students (as % of total students) in Pakistan?
Provide a succinct answer. 3.85. In the year 2011, what is the difference between the Female students (as % of total students) of Aruba and Female students (as % of total students) of Djibouti?
Your response must be concise. 1.38. In the year 2011, what is the difference between the Female students (as % of total students) of Aruba and Female students (as % of total students) of Pakistan?
Make the answer very short. 4.23. In the year 2011, what is the difference between the Female students (as % of total students) in Djibouti and Female students (as % of total students) in Pakistan?
Provide a succinct answer. 2.85. What is the ratio of the Female students (as % of total students) of Pacific island small states in 2002 to that in 2004?
Your answer should be very brief. 1. What is the ratio of the Female students (as % of total students) in Aruba in 2002 to that in 2004?
Provide a short and direct response. 1.01. What is the ratio of the Female students (as % of total students) of Djibouti in 2002 to that in 2004?
Offer a very short reply. 0.98. What is the ratio of the Female students (as % of total students) in Pakistan in 2002 to that in 2004?
Give a very brief answer. 0.96. What is the ratio of the Female students (as % of total students) of Pacific island small states in 2002 to that in 2005?
Keep it short and to the point. 1. What is the ratio of the Female students (as % of total students) in Djibouti in 2002 to that in 2005?
Your response must be concise. 0.96. What is the ratio of the Female students (as % of total students) of Pakistan in 2002 to that in 2005?
Provide a succinct answer. 0.94. What is the ratio of the Female students (as % of total students) in Pacific island small states in 2002 to that in 2006?
Provide a short and direct response. 1. What is the ratio of the Female students (as % of total students) in Aruba in 2002 to that in 2006?
Provide a short and direct response. 0.99. What is the ratio of the Female students (as % of total students) in Djibouti in 2002 to that in 2006?
Provide a succinct answer. 0.97. What is the ratio of the Female students (as % of total students) in Pakistan in 2002 to that in 2006?
Your answer should be very brief. 0.92. What is the ratio of the Female students (as % of total students) in Djibouti in 2002 to that in 2007?
Give a very brief answer. 0.94. What is the ratio of the Female students (as % of total students) of Pakistan in 2002 to that in 2007?
Make the answer very short. 0.9. What is the ratio of the Female students (as % of total students) in Pacific island small states in 2002 to that in 2008?
Keep it short and to the point. 1. What is the ratio of the Female students (as % of total students) of Aruba in 2002 to that in 2008?
Provide a short and direct response. 0.99. What is the ratio of the Female students (as % of total students) in Djibouti in 2002 to that in 2008?
Provide a succinct answer. 0.92. What is the ratio of the Female students (as % of total students) in Pakistan in 2002 to that in 2008?
Keep it short and to the point. 0.89. What is the ratio of the Female students (as % of total students) in Pacific island small states in 2002 to that in 2009?
Provide a succinct answer. 1. What is the ratio of the Female students (as % of total students) of Aruba in 2002 to that in 2009?
Your answer should be compact. 0.99. What is the ratio of the Female students (as % of total students) of Djibouti in 2002 to that in 2009?
Provide a short and direct response. 0.92. What is the ratio of the Female students (as % of total students) of Pakistan in 2002 to that in 2009?
Offer a terse response. 0.89. What is the ratio of the Female students (as % of total students) of Pacific island small states in 2002 to that in 2011?
Your response must be concise. 1. What is the ratio of the Female students (as % of total students) in Aruba in 2002 to that in 2011?
Your response must be concise. 1. What is the ratio of the Female students (as % of total students) of Djibouti in 2002 to that in 2011?
Provide a short and direct response. 0.91. What is the ratio of the Female students (as % of total students) in Pakistan in 2002 to that in 2011?
Your answer should be compact. 0.89. What is the ratio of the Female students (as % of total students) of Pacific island small states in 2004 to that in 2005?
Keep it short and to the point. 1. What is the ratio of the Female students (as % of total students) of Djibouti in 2004 to that in 2005?
Provide a short and direct response. 0.98. What is the ratio of the Female students (as % of total students) of Pakistan in 2004 to that in 2005?
Your response must be concise. 0.97. What is the ratio of the Female students (as % of total students) in Aruba in 2004 to that in 2006?
Offer a very short reply. 0.98. What is the ratio of the Female students (as % of total students) of Djibouti in 2004 to that in 2006?
Offer a very short reply. 0.99. What is the ratio of the Female students (as % of total students) in Pakistan in 2004 to that in 2006?
Provide a succinct answer. 0.96. What is the ratio of the Female students (as % of total students) in Pacific island small states in 2004 to that in 2007?
Provide a succinct answer. 1. What is the ratio of the Female students (as % of total students) in Aruba in 2004 to that in 2007?
Your answer should be very brief. 0.99. What is the ratio of the Female students (as % of total students) in Djibouti in 2004 to that in 2007?
Provide a short and direct response. 0.96. What is the ratio of the Female students (as % of total students) in Pakistan in 2004 to that in 2007?
Your answer should be compact. 0.93. What is the ratio of the Female students (as % of total students) in Pacific island small states in 2004 to that in 2008?
Give a very brief answer. 1. What is the ratio of the Female students (as % of total students) in Aruba in 2004 to that in 2008?
Provide a short and direct response. 0.99. What is the ratio of the Female students (as % of total students) of Djibouti in 2004 to that in 2008?
Your answer should be very brief. 0.94. What is the ratio of the Female students (as % of total students) of Pakistan in 2004 to that in 2008?
Ensure brevity in your answer.  0.93. What is the ratio of the Female students (as % of total students) in Pacific island small states in 2004 to that in 2009?
Your answer should be very brief. 1. What is the ratio of the Female students (as % of total students) in Aruba in 2004 to that in 2009?
Provide a short and direct response. 0.98. What is the ratio of the Female students (as % of total students) in Djibouti in 2004 to that in 2009?
Give a very brief answer. 0.94. What is the ratio of the Female students (as % of total students) in Pakistan in 2004 to that in 2009?
Your answer should be compact. 0.92. What is the ratio of the Female students (as % of total students) in Pacific island small states in 2004 to that in 2011?
Your answer should be compact. 0.99. What is the ratio of the Female students (as % of total students) in Aruba in 2004 to that in 2011?
Ensure brevity in your answer.  0.99. What is the ratio of the Female students (as % of total students) in Djibouti in 2004 to that in 2011?
Provide a succinct answer. 0.93. What is the ratio of the Female students (as % of total students) of Pakistan in 2004 to that in 2011?
Your answer should be compact. 0.92. What is the ratio of the Female students (as % of total students) of Djibouti in 2005 to that in 2006?
Keep it short and to the point. 1. What is the ratio of the Female students (as % of total students) in Pakistan in 2005 to that in 2006?
Your answer should be very brief. 0.99. What is the ratio of the Female students (as % of total students) in Djibouti in 2005 to that in 2007?
Your answer should be very brief. 0.97. What is the ratio of the Female students (as % of total students) of Pakistan in 2005 to that in 2007?
Your answer should be compact. 0.96. What is the ratio of the Female students (as % of total students) of Pacific island small states in 2005 to that in 2008?
Provide a succinct answer. 1. What is the ratio of the Female students (as % of total students) in Djibouti in 2005 to that in 2008?
Give a very brief answer. 0.96. What is the ratio of the Female students (as % of total students) of Pakistan in 2005 to that in 2008?
Your answer should be compact. 0.95. What is the ratio of the Female students (as % of total students) in Djibouti in 2005 to that in 2009?
Provide a short and direct response. 0.95. What is the ratio of the Female students (as % of total students) in Pakistan in 2005 to that in 2009?
Give a very brief answer. 0.95. What is the ratio of the Female students (as % of total students) in Pacific island small states in 2005 to that in 2011?
Your answer should be compact. 1. What is the ratio of the Female students (as % of total students) in Aruba in 2005 to that in 2011?
Your answer should be compact. 1. What is the ratio of the Female students (as % of total students) in Djibouti in 2005 to that in 2011?
Offer a very short reply. 0.95. What is the ratio of the Female students (as % of total students) of Pakistan in 2005 to that in 2011?
Ensure brevity in your answer.  0.95. What is the ratio of the Female students (as % of total students) in Pacific island small states in 2006 to that in 2007?
Your response must be concise. 1. What is the ratio of the Female students (as % of total students) of Aruba in 2006 to that in 2007?
Your answer should be compact. 1. What is the ratio of the Female students (as % of total students) of Djibouti in 2006 to that in 2007?
Provide a succinct answer. 0.97. What is the ratio of the Female students (as % of total students) in Pakistan in 2006 to that in 2007?
Your answer should be very brief. 0.97. What is the ratio of the Female students (as % of total students) in Pacific island small states in 2006 to that in 2008?
Ensure brevity in your answer.  1. What is the ratio of the Female students (as % of total students) in Djibouti in 2006 to that in 2008?
Ensure brevity in your answer.  0.95. What is the ratio of the Female students (as % of total students) in Pakistan in 2006 to that in 2008?
Ensure brevity in your answer.  0.97. What is the ratio of the Female students (as % of total students) of Djibouti in 2006 to that in 2009?
Give a very brief answer. 0.95. What is the ratio of the Female students (as % of total students) in Pakistan in 2006 to that in 2009?
Keep it short and to the point. 0.96. What is the ratio of the Female students (as % of total students) in Aruba in 2006 to that in 2011?
Provide a succinct answer. 1.01. What is the ratio of the Female students (as % of total students) in Djibouti in 2006 to that in 2011?
Provide a short and direct response. 0.95. What is the ratio of the Female students (as % of total students) of Pakistan in 2006 to that in 2011?
Provide a short and direct response. 0.96. What is the ratio of the Female students (as % of total students) in Djibouti in 2007 to that in 2008?
Keep it short and to the point. 0.98. What is the ratio of the Female students (as % of total students) in Pakistan in 2007 to that in 2008?
Give a very brief answer. 1. What is the ratio of the Female students (as % of total students) in Djibouti in 2007 to that in 2009?
Offer a very short reply. 0.98. What is the ratio of the Female students (as % of total students) in Pakistan in 2007 to that in 2009?
Make the answer very short. 0.99. What is the ratio of the Female students (as % of total students) of Pacific island small states in 2007 to that in 2011?
Your answer should be very brief. 0.99. What is the ratio of the Female students (as % of total students) of Aruba in 2007 to that in 2011?
Offer a very short reply. 1. What is the ratio of the Female students (as % of total students) in Djibouti in 2007 to that in 2011?
Ensure brevity in your answer.  0.97. What is the ratio of the Female students (as % of total students) of Pakistan in 2007 to that in 2011?
Give a very brief answer. 0.99. What is the ratio of the Female students (as % of total students) in Djibouti in 2008 to that in 2009?
Provide a succinct answer. 1. What is the ratio of the Female students (as % of total students) in Djibouti in 2008 to that in 2011?
Ensure brevity in your answer.  0.99. What is the ratio of the Female students (as % of total students) of Pakistan in 2008 to that in 2011?
Provide a short and direct response. 0.99. What is the difference between the highest and the second highest Female students (as % of total students) in Pacific island small states?
Provide a short and direct response. 0.1. What is the difference between the highest and the second highest Female students (as % of total students) in Aruba?
Give a very brief answer. 0.16. What is the difference between the highest and the second highest Female students (as % of total students) of Djibouti?
Your response must be concise. 0.26. What is the difference between the highest and the second highest Female students (as % of total students) in Pakistan?
Provide a succinct answer. 0.04. What is the difference between the highest and the lowest Female students (as % of total students) of Pacific island small states?
Offer a terse response. 0.3. What is the difference between the highest and the lowest Female students (as % of total students) of Aruba?
Provide a succinct answer. 0.92. What is the difference between the highest and the lowest Female students (as % of total students) in Djibouti?
Ensure brevity in your answer.  4.07. What is the difference between the highest and the lowest Female students (as % of total students) in Pakistan?
Your answer should be very brief. 5. 